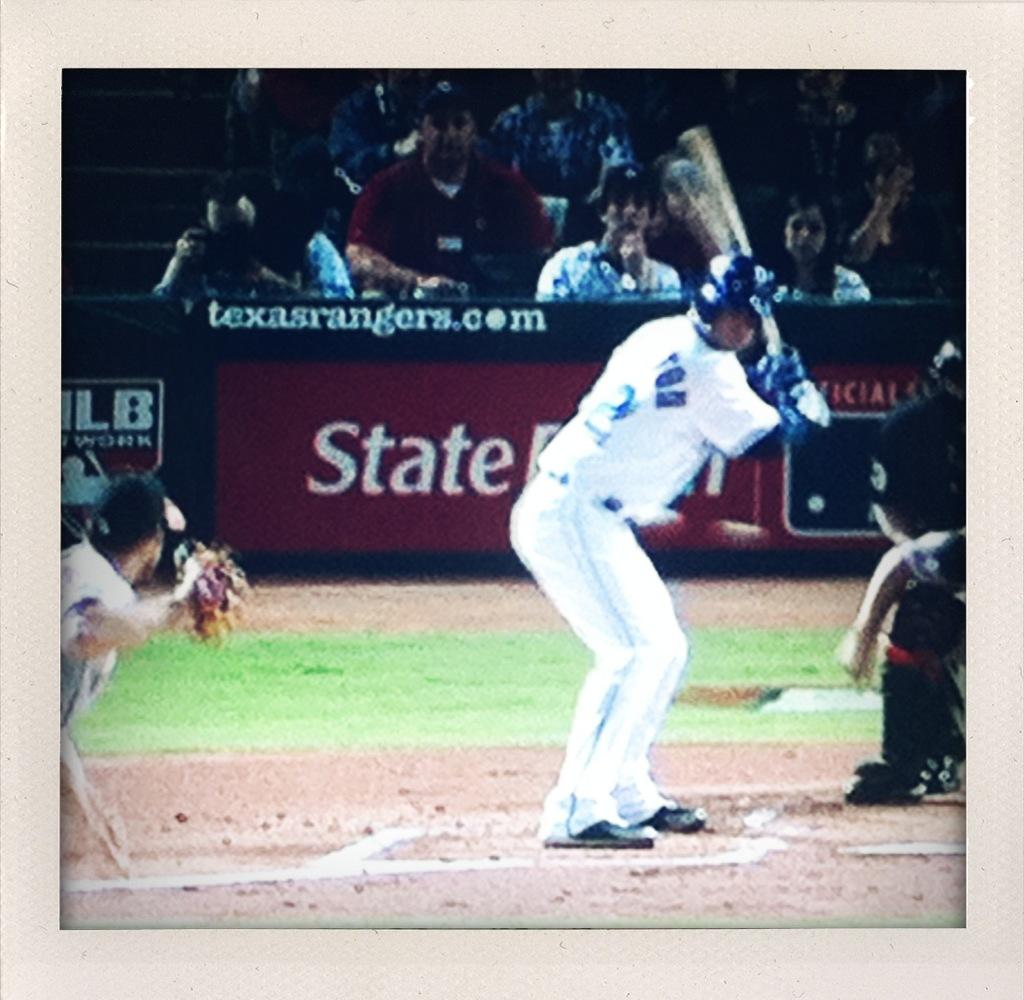<image>
Summarize the visual content of the image. A player is at-bat, in front of an advertisement for texasrangers.com. 